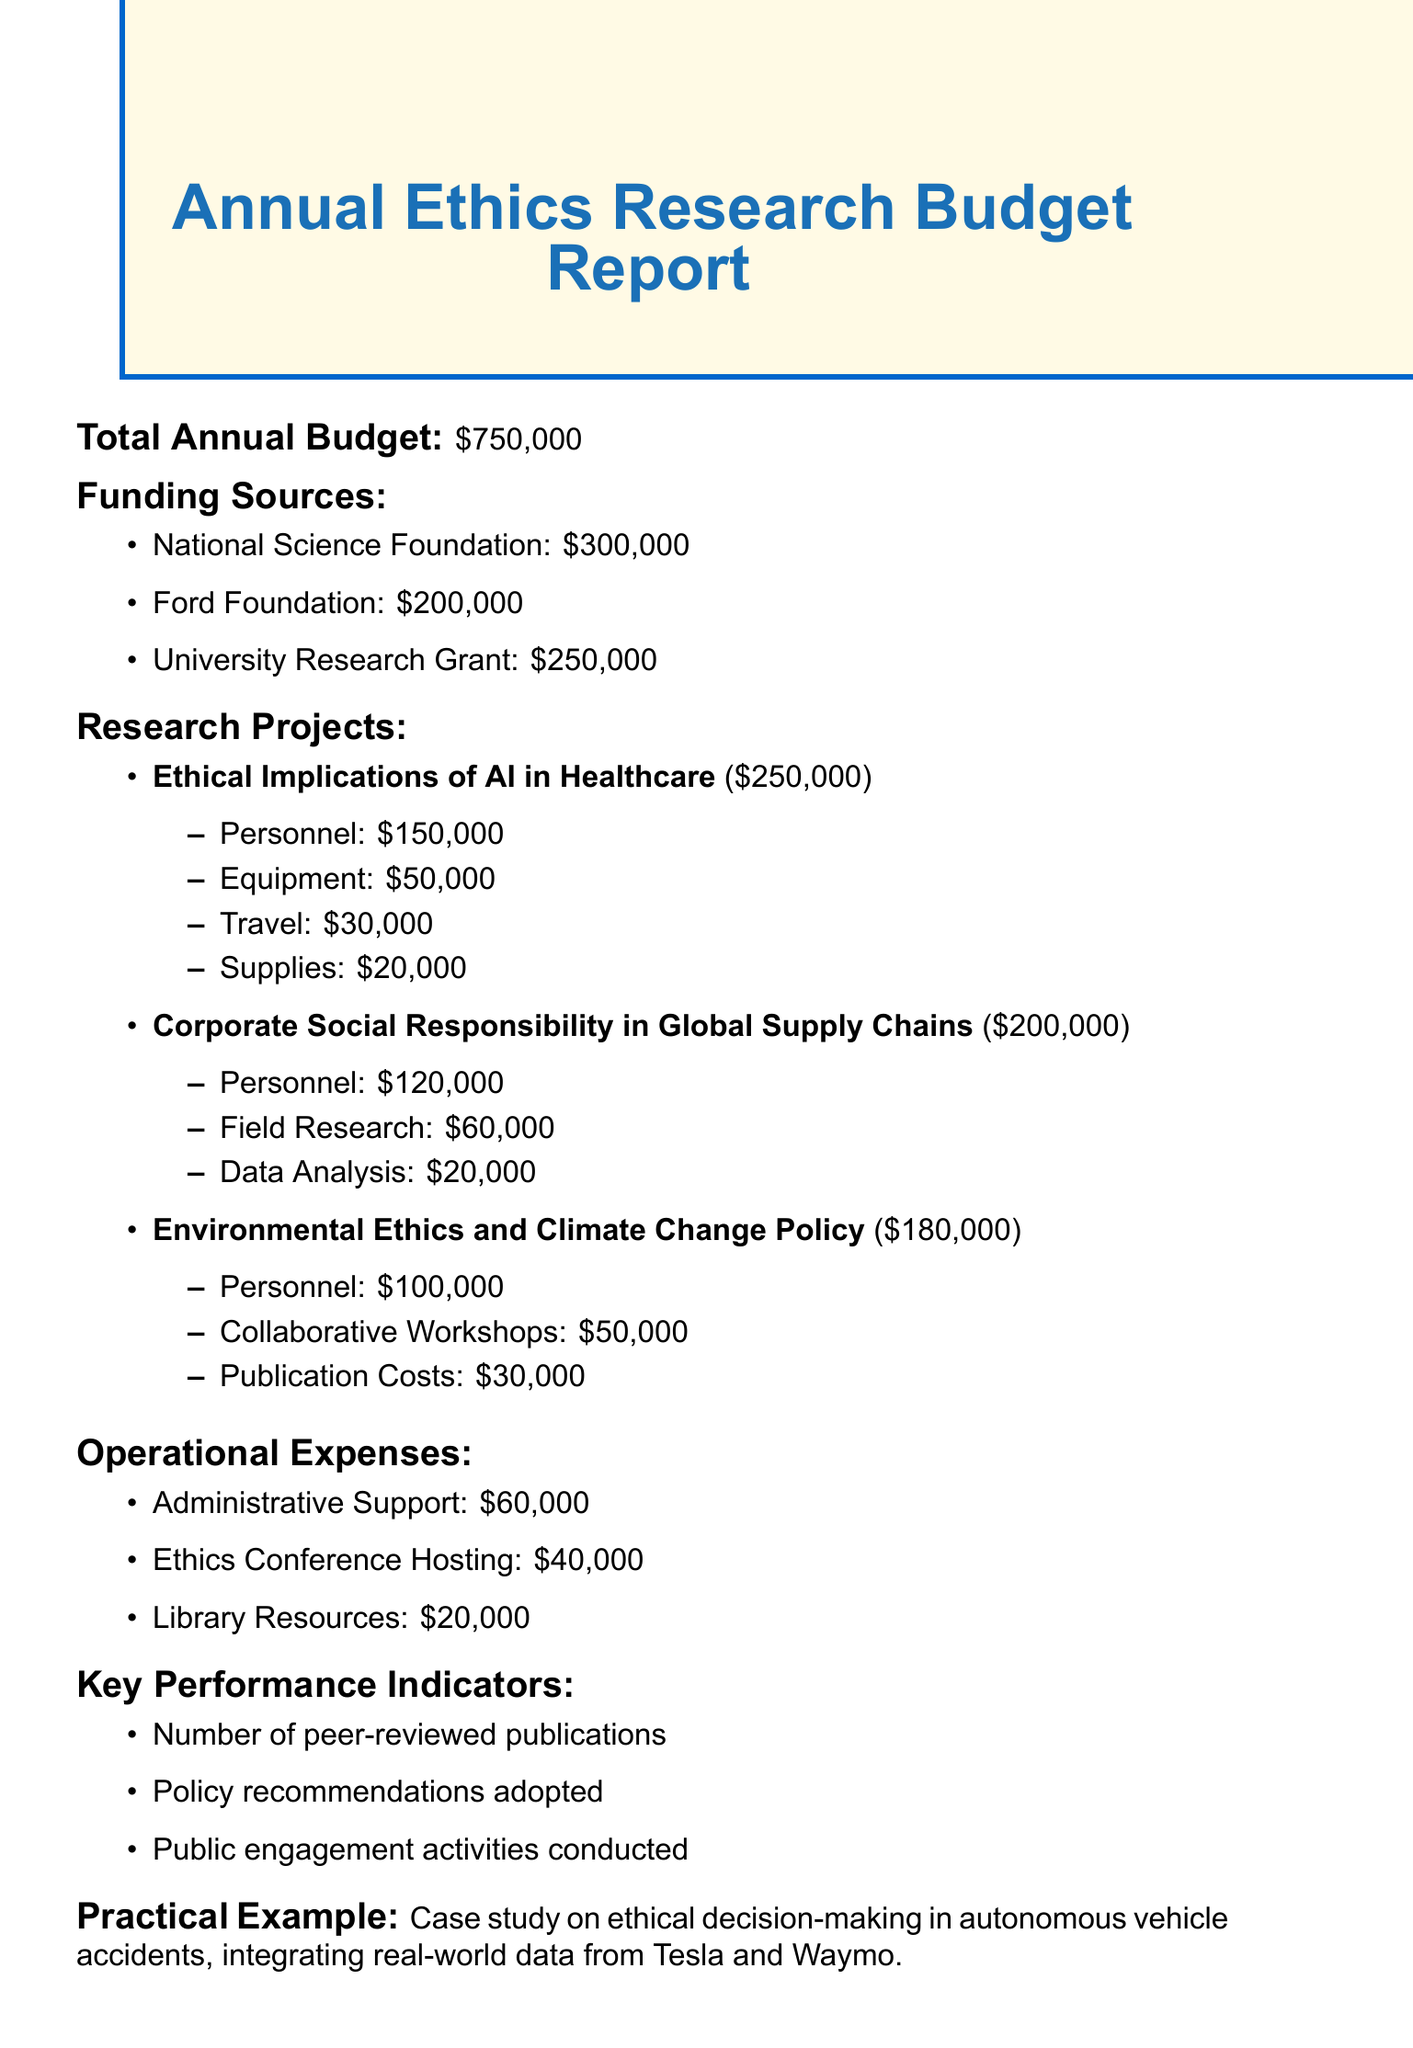What is the total annual budget? The total annual budget is stated clearly in the document, which is $750,000.
Answer: $750,000 Who is the largest funding source? The largest funding source can be retrieved from the funding sources section, where the National Science Foundation is listed with the amount of $300,000.
Answer: National Science Foundation How much is allocated to the project on "Environmental Ethics and Climate Change Policy"? The allocation for "Environmental Ethics and Climate Change Policy" can be found in the research projects section, noted as $180,000.
Answer: $180,000 What is the total amount allocated to personnel across all projects? To find the total amount allocated to personnel, sum the personnel costs from all research projects: $150,000 + $120,000 + $100,000 = $370,000.
Answer: $370,000 What percentage of the total budget is allocated to operational expenses? The total operational expenses from the document can be calculated as $60,000 + $40,000 + $20,000 = $120,000, and to find the percentage of the total budget: ($120,000 / $750,000) * 100 = 16%.
Answer: 16% What is a key performance indicator mentioned in the report? The key performance indicators are listed in the document, among which one example is the number of peer-reviewed publications.
Answer: Number of peer-reviewed publications How much funding is allocated for equipment in the "Ethical Implications of AI in Healthcare" project? The funding for equipment in that specific project can be found in its breakdown, which shows $50,000 allocated for equipment.
Answer: $50,000 Which practical example is discussed in the report? The practical example mentioned in the report is the case study on ethical decision-making in autonomous vehicle accidents, integrating real-world data from Tesla and Waymo.
Answer: Case study on ethical decision-making in autonomous vehicle accidents What is the total funding from the Ford Foundation? The funding from the Ford Foundation is clearly specified in the funding sources section, which is $200,000.
Answer: $200,000 